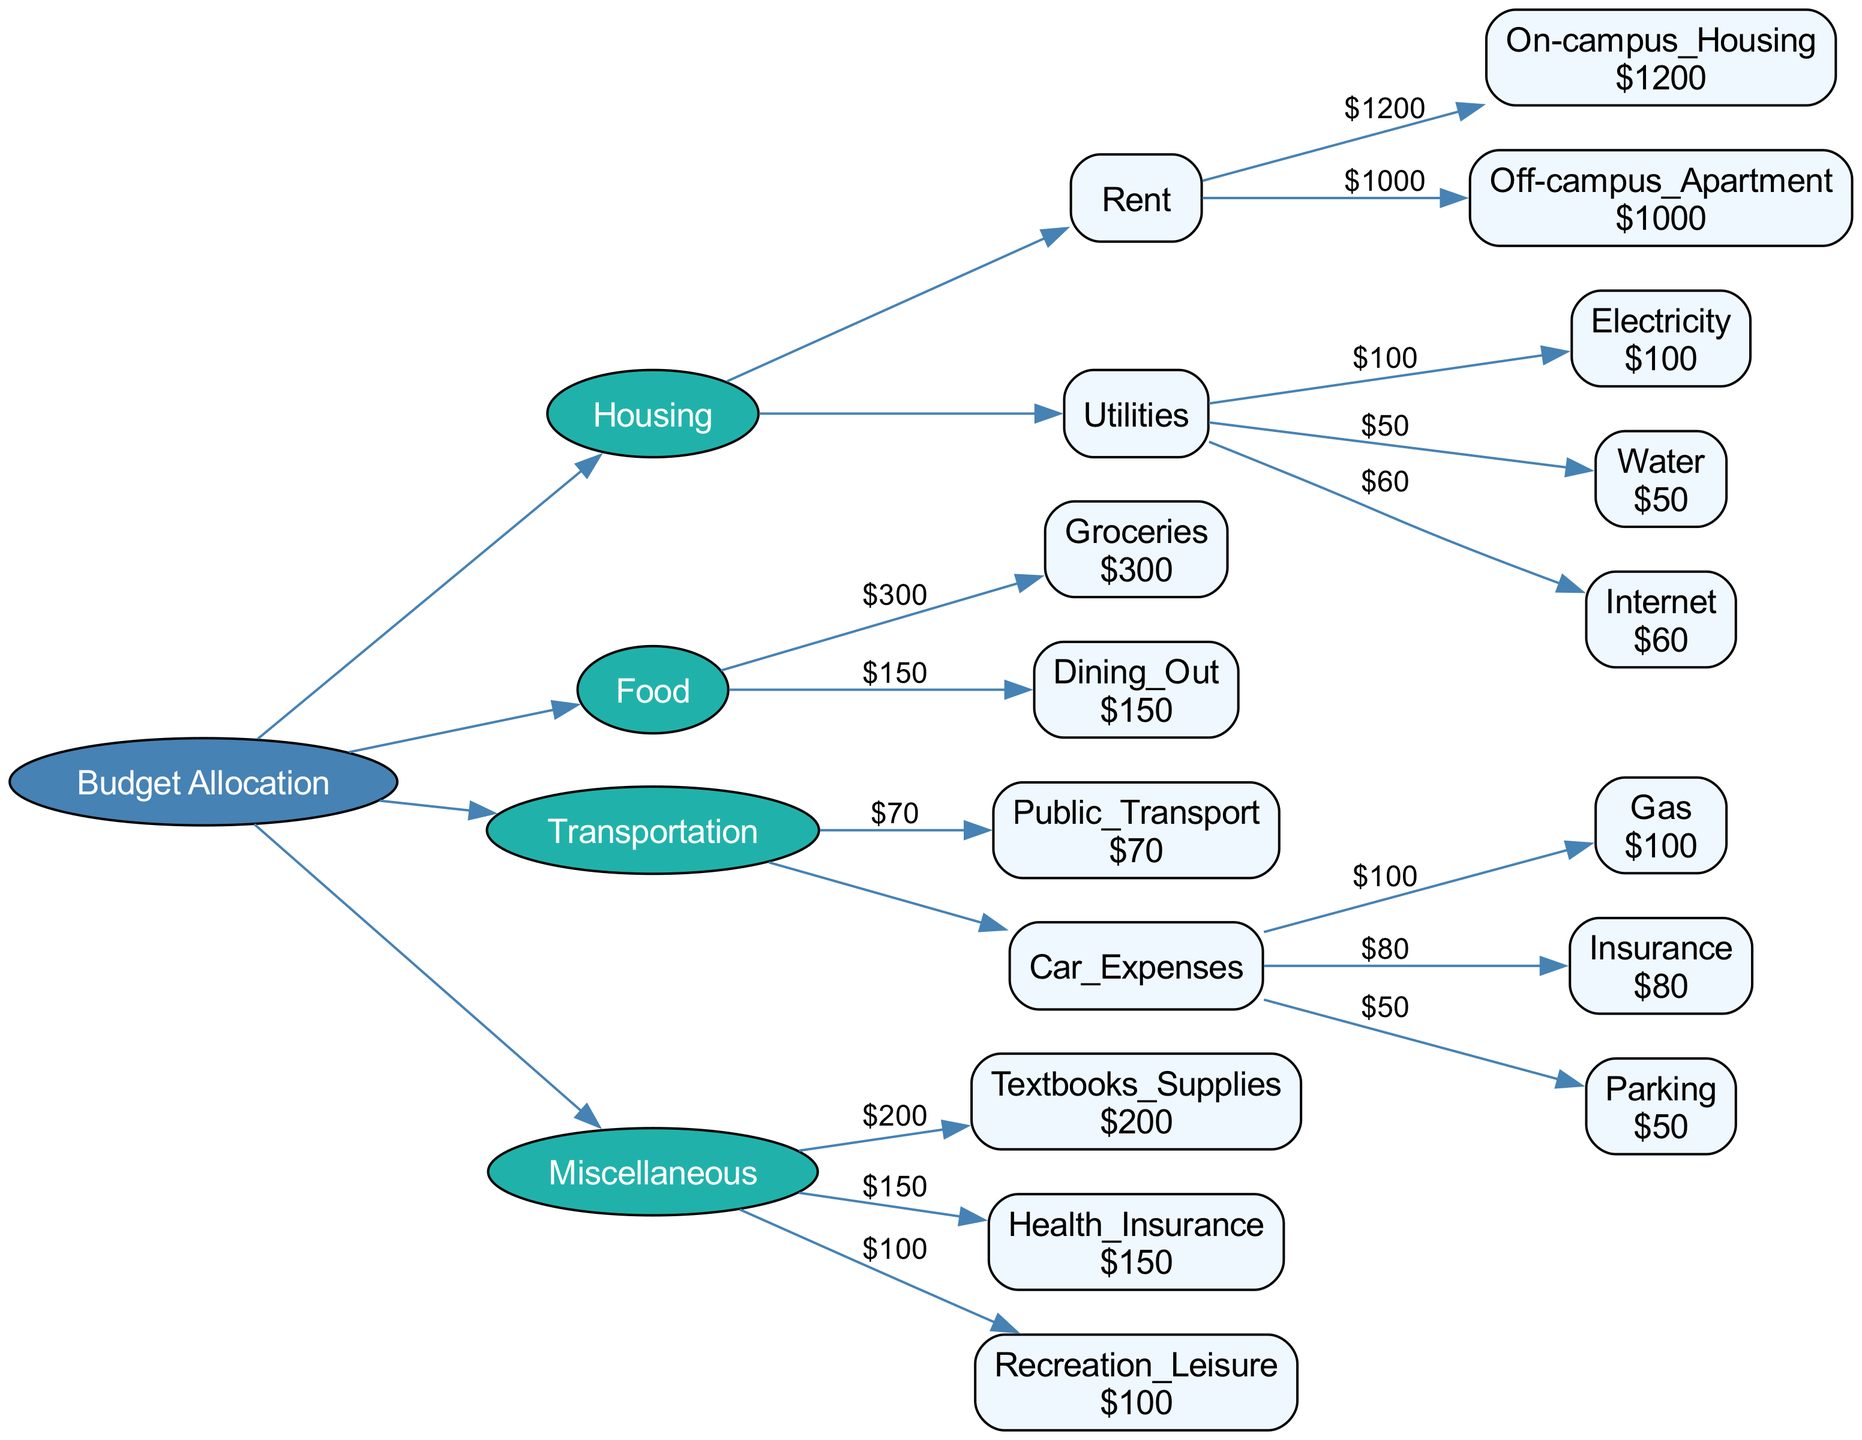What is the total budget for Housing? The total budget for Housing is the sum of Rent and Utilities. For Rent, either On-campus Housing is $1200 or Off-campus Apartment is $1000. For Utilities, Electricity is $100, Water is $50, and Internet is $60. Thus, Rent + Utilities = (can choose $1200 or $1000) + ($100 + $50 + $60 = $210). Selecting On-campus Housing, total is $1200 + $210 = $1410
Answer: $1410 How much is allocated for Dining Out? The budget allocation for Dining Out is clearly specified in the diagram as $150. Therefore, the amount allocated is taken directly from the corresponding node in the Food category
Answer: $150 What is the cost of Health Insurance? The Health Insurance cost specified in the diagram is $150, which is indicated directly in the Miscellaneous category under Health Insurance
Answer: $150 How many expenses are included in the Transportation category? The Transportation category has three main expenses: Public Transport, and two expenses under Car Expenses (Gas, Insurance, Parking). Therefore, adding these all together gives a total of 5 expenses in the Transportation category
Answer: 5 Which option has a higher cost, On-campus Housing or Off-campus Apartment? In the diagram, On-campus Housing costs $1200 while Off-campus Apartment costs $1000. Therefore, comparing the two, On-campus Housing is the higher cost option at $1200
Answer: On-campus Housing What is the total cost for Car Expenses? Car Expenses comprise three individual expenses: Gas ($100), Insurance ($80), and Parking ($50). To find the total for Car Expenses, we add these amounts together: $100 + $80 + $50 = $230. This gives the overall total cost for Car Expenses
Answer: $230 Which category has the highest single expense? To determine the category with the highest single expense, we look through all the expenses specified. The highest expense is found in Rent (On-campus Housing at $1200). Thus, this is the category with the highest single expense overall
Answer: Rent How much is allocated for Recreation Leisure? The budget for Recreation Leisure is listed directly in the Miscellaneous section as $100. Thus, the amount allocated for Recreation Leisure is simply taken as stated in the diagram
Answer: $100 What is the total for all the Utilities combined? The Utilities are defined as Electricity ($100), Water ($50), and Internet ($60). To find the total for Utilities, we sum these values: $100 + $50 + $60, which equals $210. So, the total for all the Utilities combined is $210
Answer: $210 